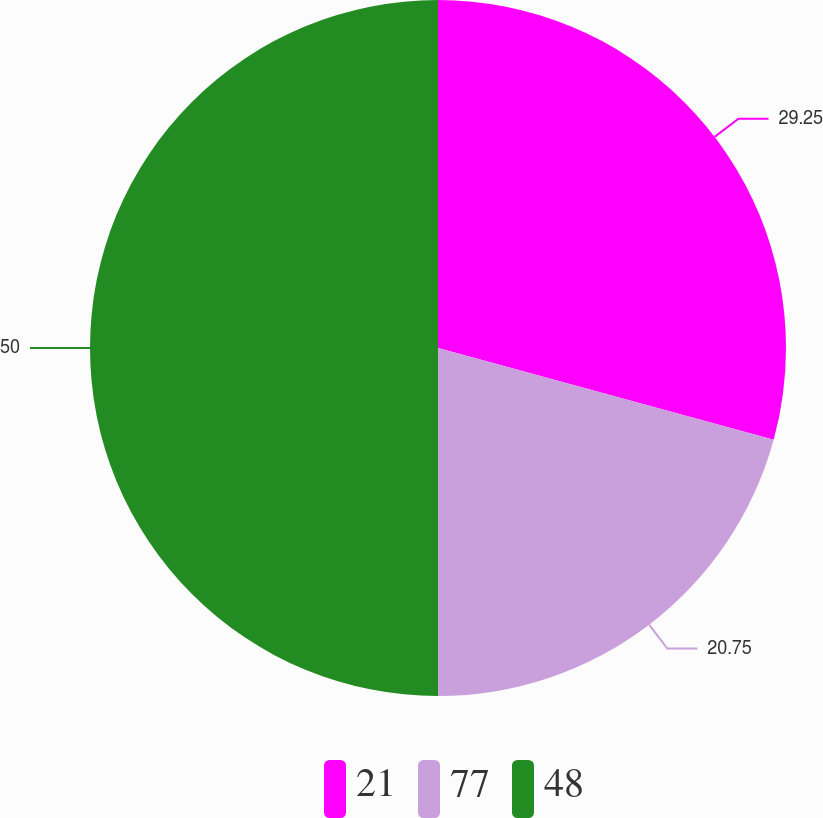<chart> <loc_0><loc_0><loc_500><loc_500><pie_chart><fcel>21<fcel>77<fcel>48<nl><fcel>29.25%<fcel>20.75%<fcel>50.0%<nl></chart> 